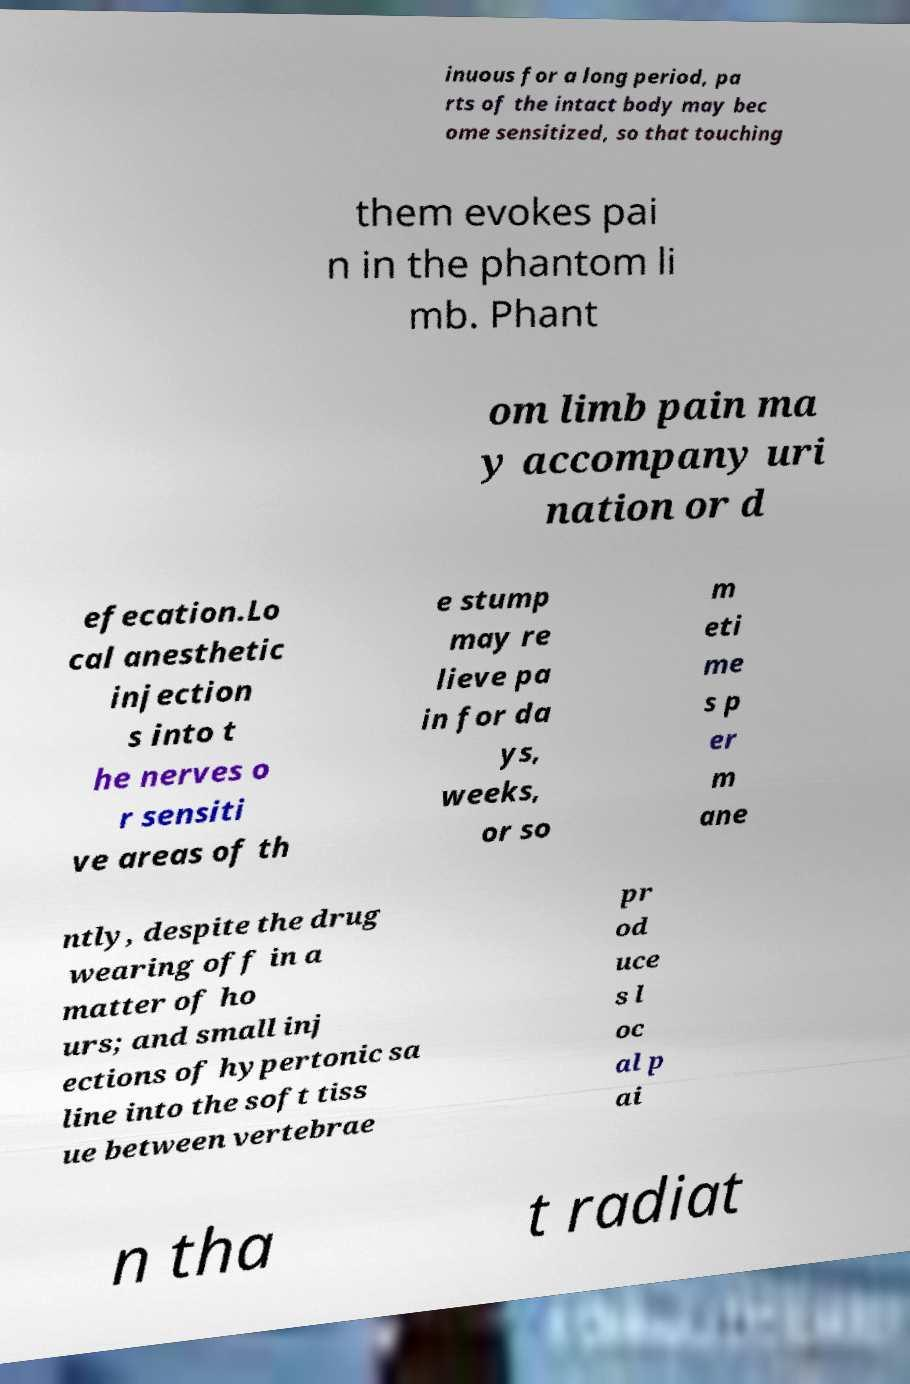Please identify and transcribe the text found in this image. inuous for a long period, pa rts of the intact body may bec ome sensitized, so that touching them evokes pai n in the phantom li mb. Phant om limb pain ma y accompany uri nation or d efecation.Lo cal anesthetic injection s into t he nerves o r sensiti ve areas of th e stump may re lieve pa in for da ys, weeks, or so m eti me s p er m ane ntly, despite the drug wearing off in a matter of ho urs; and small inj ections of hypertonic sa line into the soft tiss ue between vertebrae pr od uce s l oc al p ai n tha t radiat 